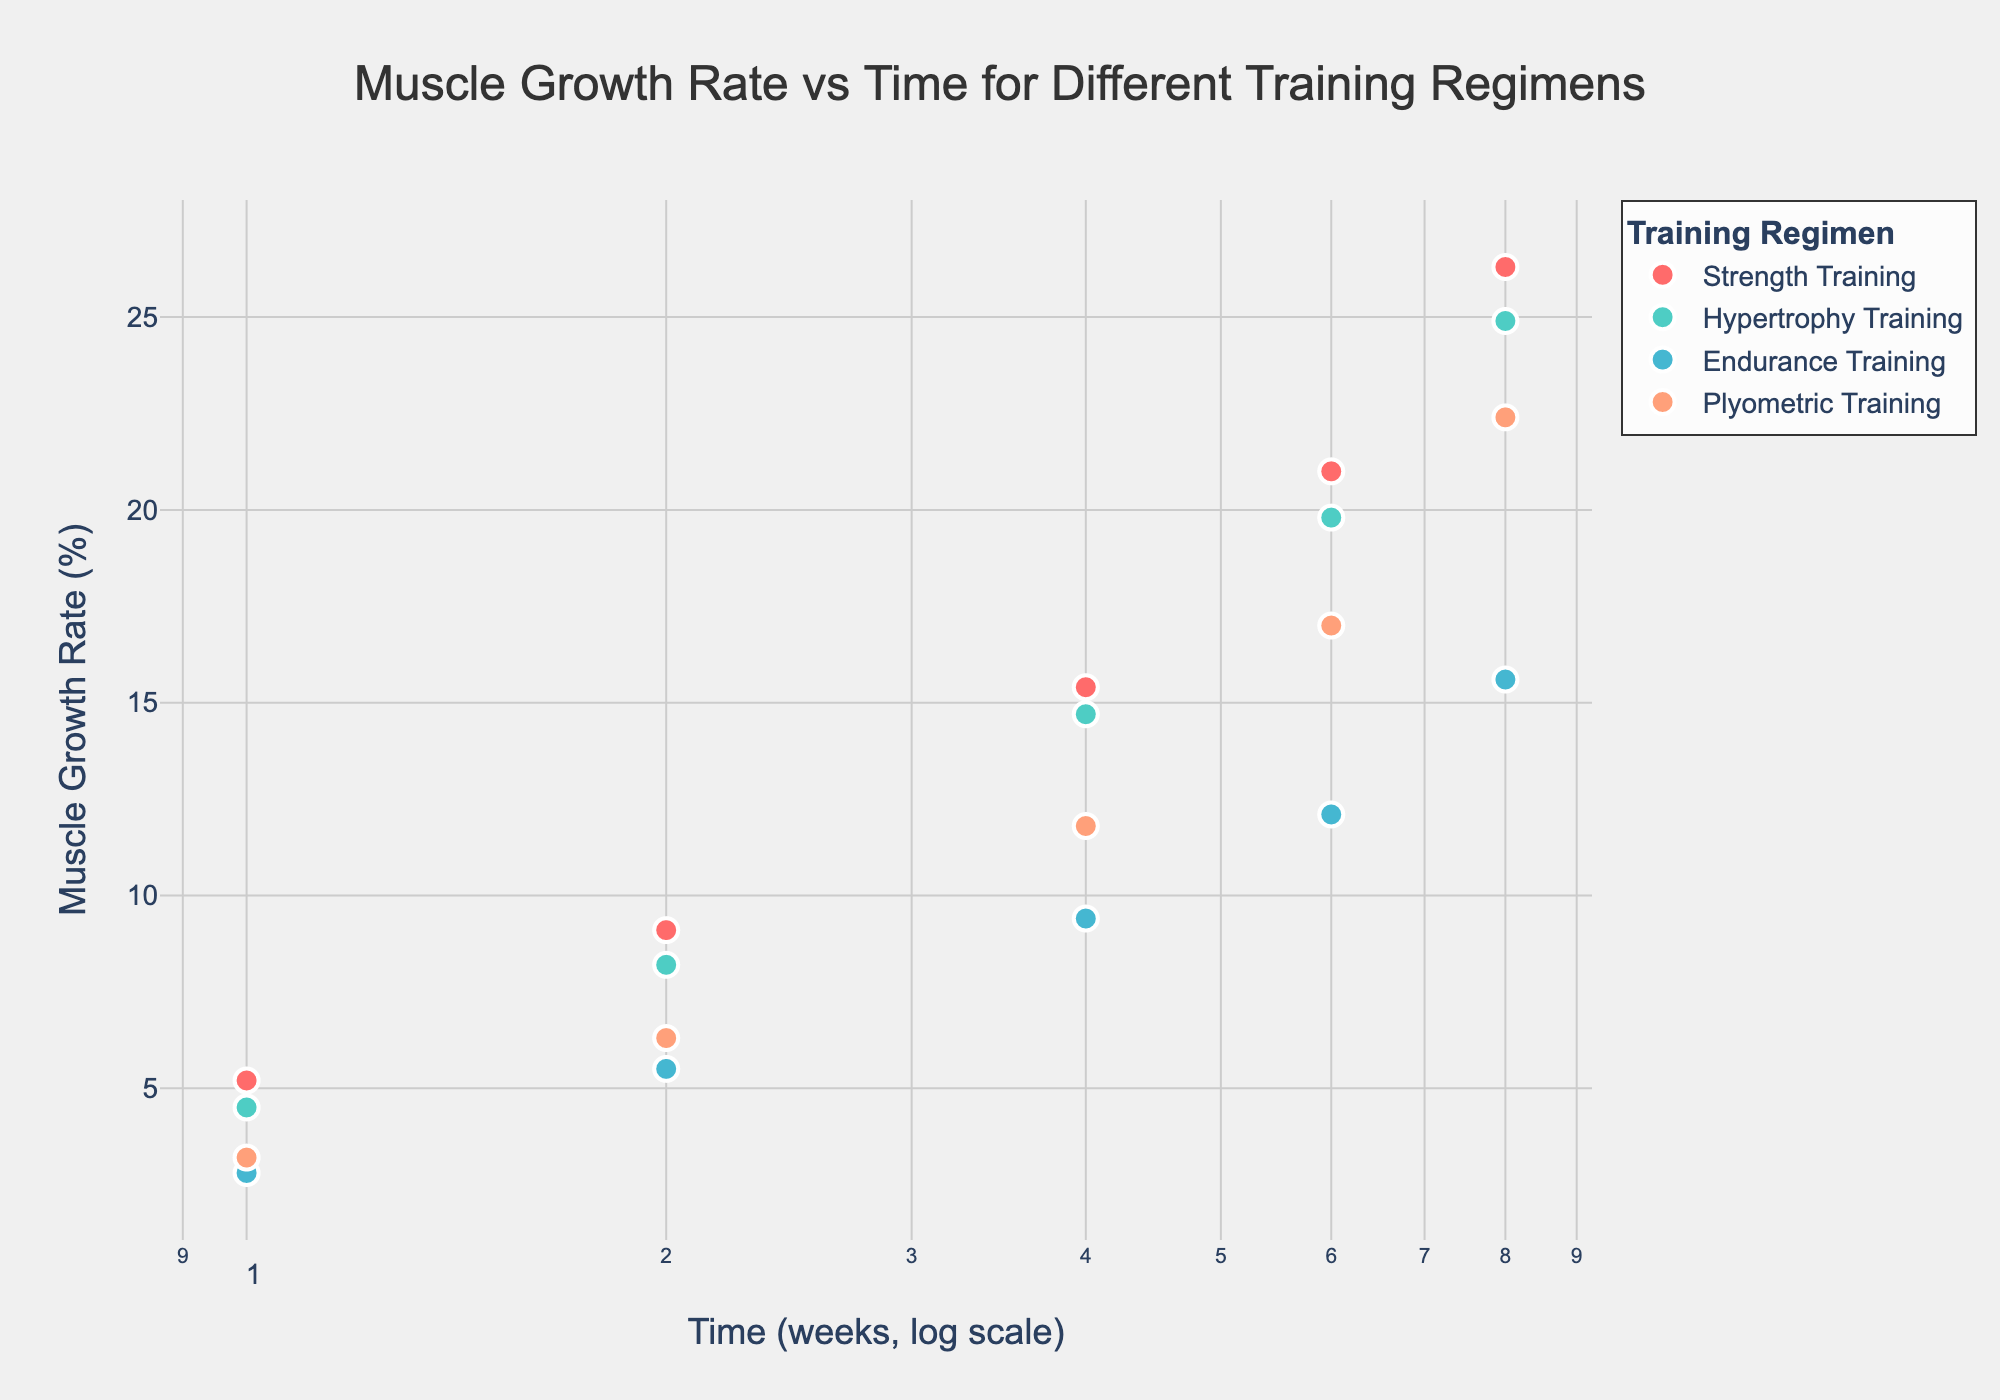What is the title of the figure? The title is usually found at the top of the figure. Here, it is located in the center of the plot and states what the figure is about.
Answer: Muscle Growth Rate vs Time for Different Training Regimens How many training regimens are shown in the figure? Look for different legend entries or color-coded categories in the figure. Here, each unique color represents a different training regimen.
Answer: Four At 8 weeks, which training regimen has the highest muscle growth rate? Locate the data points for week 8 along the x-axis and compare their y-axis values (muscle growth rate).
Answer: Strength Training Between which weeks does Plyometric Training show the greatest increase in muscle growth rate? Observe the slope of the data points connected for Plyometric Training. The steepest increase (greatest difference in growth rate) will indicate the period with the greatest growth.
Answer: Between weeks 4 and 6 What is the general trend of muscle growth rate over time for all training regimens? Examine how the data points for each training type progress over time (x-axis). Generally, the direction and pattern or whether they increase, decrease, or remain constant.
Answer: Increasing Which training regimen shows the least muscle growth rate at week 1? Look for the data points at week 1 and identify which has the lowest position on the y-axis (muscle growth rate).
Answer: Endurance Training Between week 2 and week 4, which training regimen shows the second highest increase in muscle growth rate? Calculate the difference in muscle growth rate (y-axis) between week 2 and week 4 for each training regimen and sort them to find the second highest.
Answer: Plyometric Training How does the muscle growth rate for Endurance Training compare to Hypertrophy Training at week 6? Locate the week 6 points for both Endurance Training and Hypertrophy Training, then compare their y-axis values.
Answer: Hypertrophy Training has a higher growth rate What is the muscle growth rate for Hypertrophy Training at week 8? Find the data point corresponding to week 8 for Hypertrophy Training and check its y-axis value.
Answer: 24.9% Is the relationship between time and muscle growth rate linear or non-linear in this scatter plot? Observe how the data points align along the x-axis (log scale) and y-axis; a linear trend would be straight.
Answer: Non-linear 